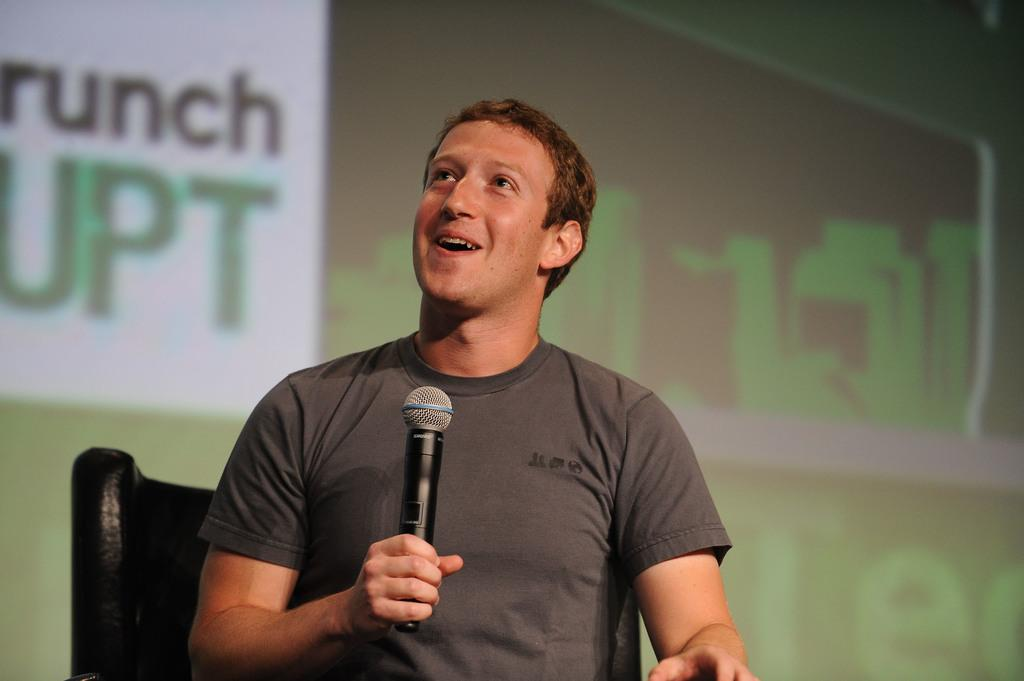Who or what is the main subject in the image? There is a person in the image. Can you describe the position of the person in the image? The person is sitting at the center of the image. What is the person holding in his hand? The person is holding a mic in his hand. What type of substance is being used to feed the babies in the image? There are no babies present in the image, and therefore no substance is being used to feed them. 